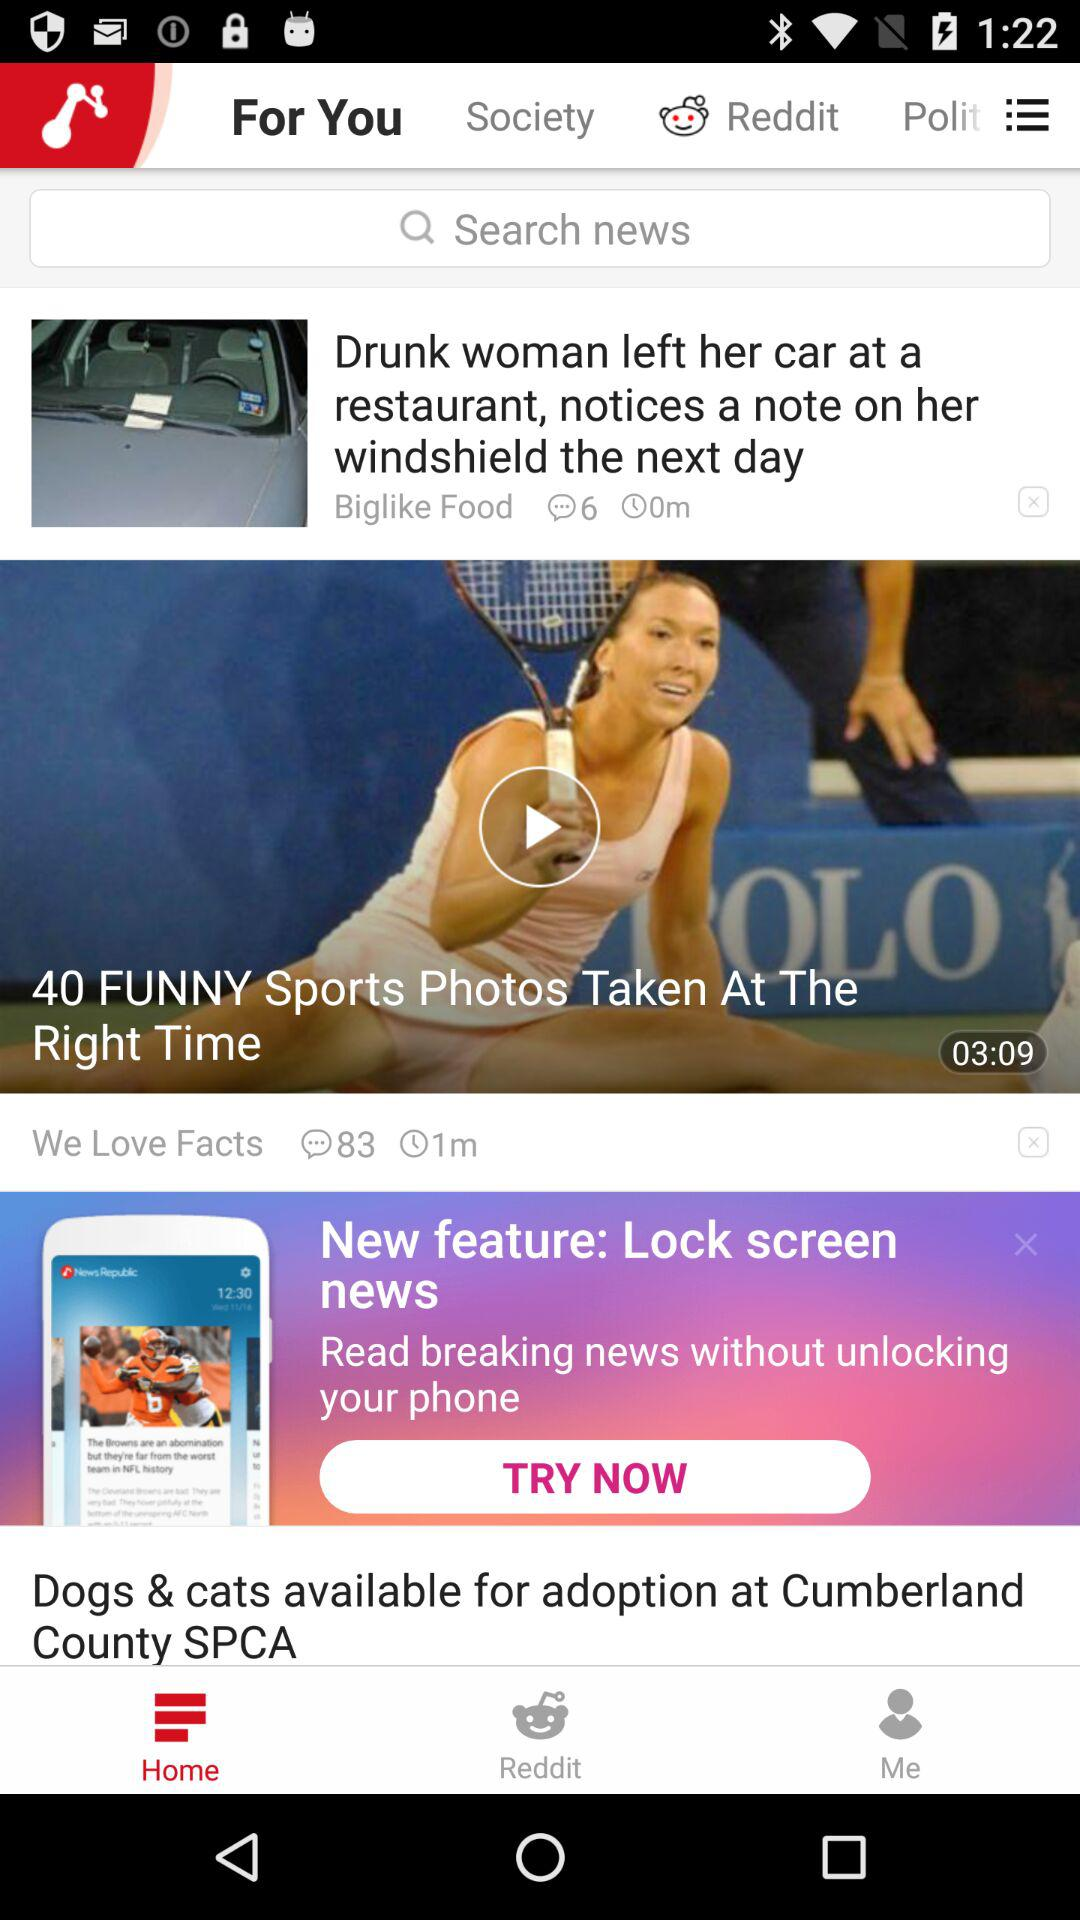What is the duration of the video "40 FUNNY Sports Photos Taken At The Right Time"? The duration of the video is 3 minutes and 9 seconds. 